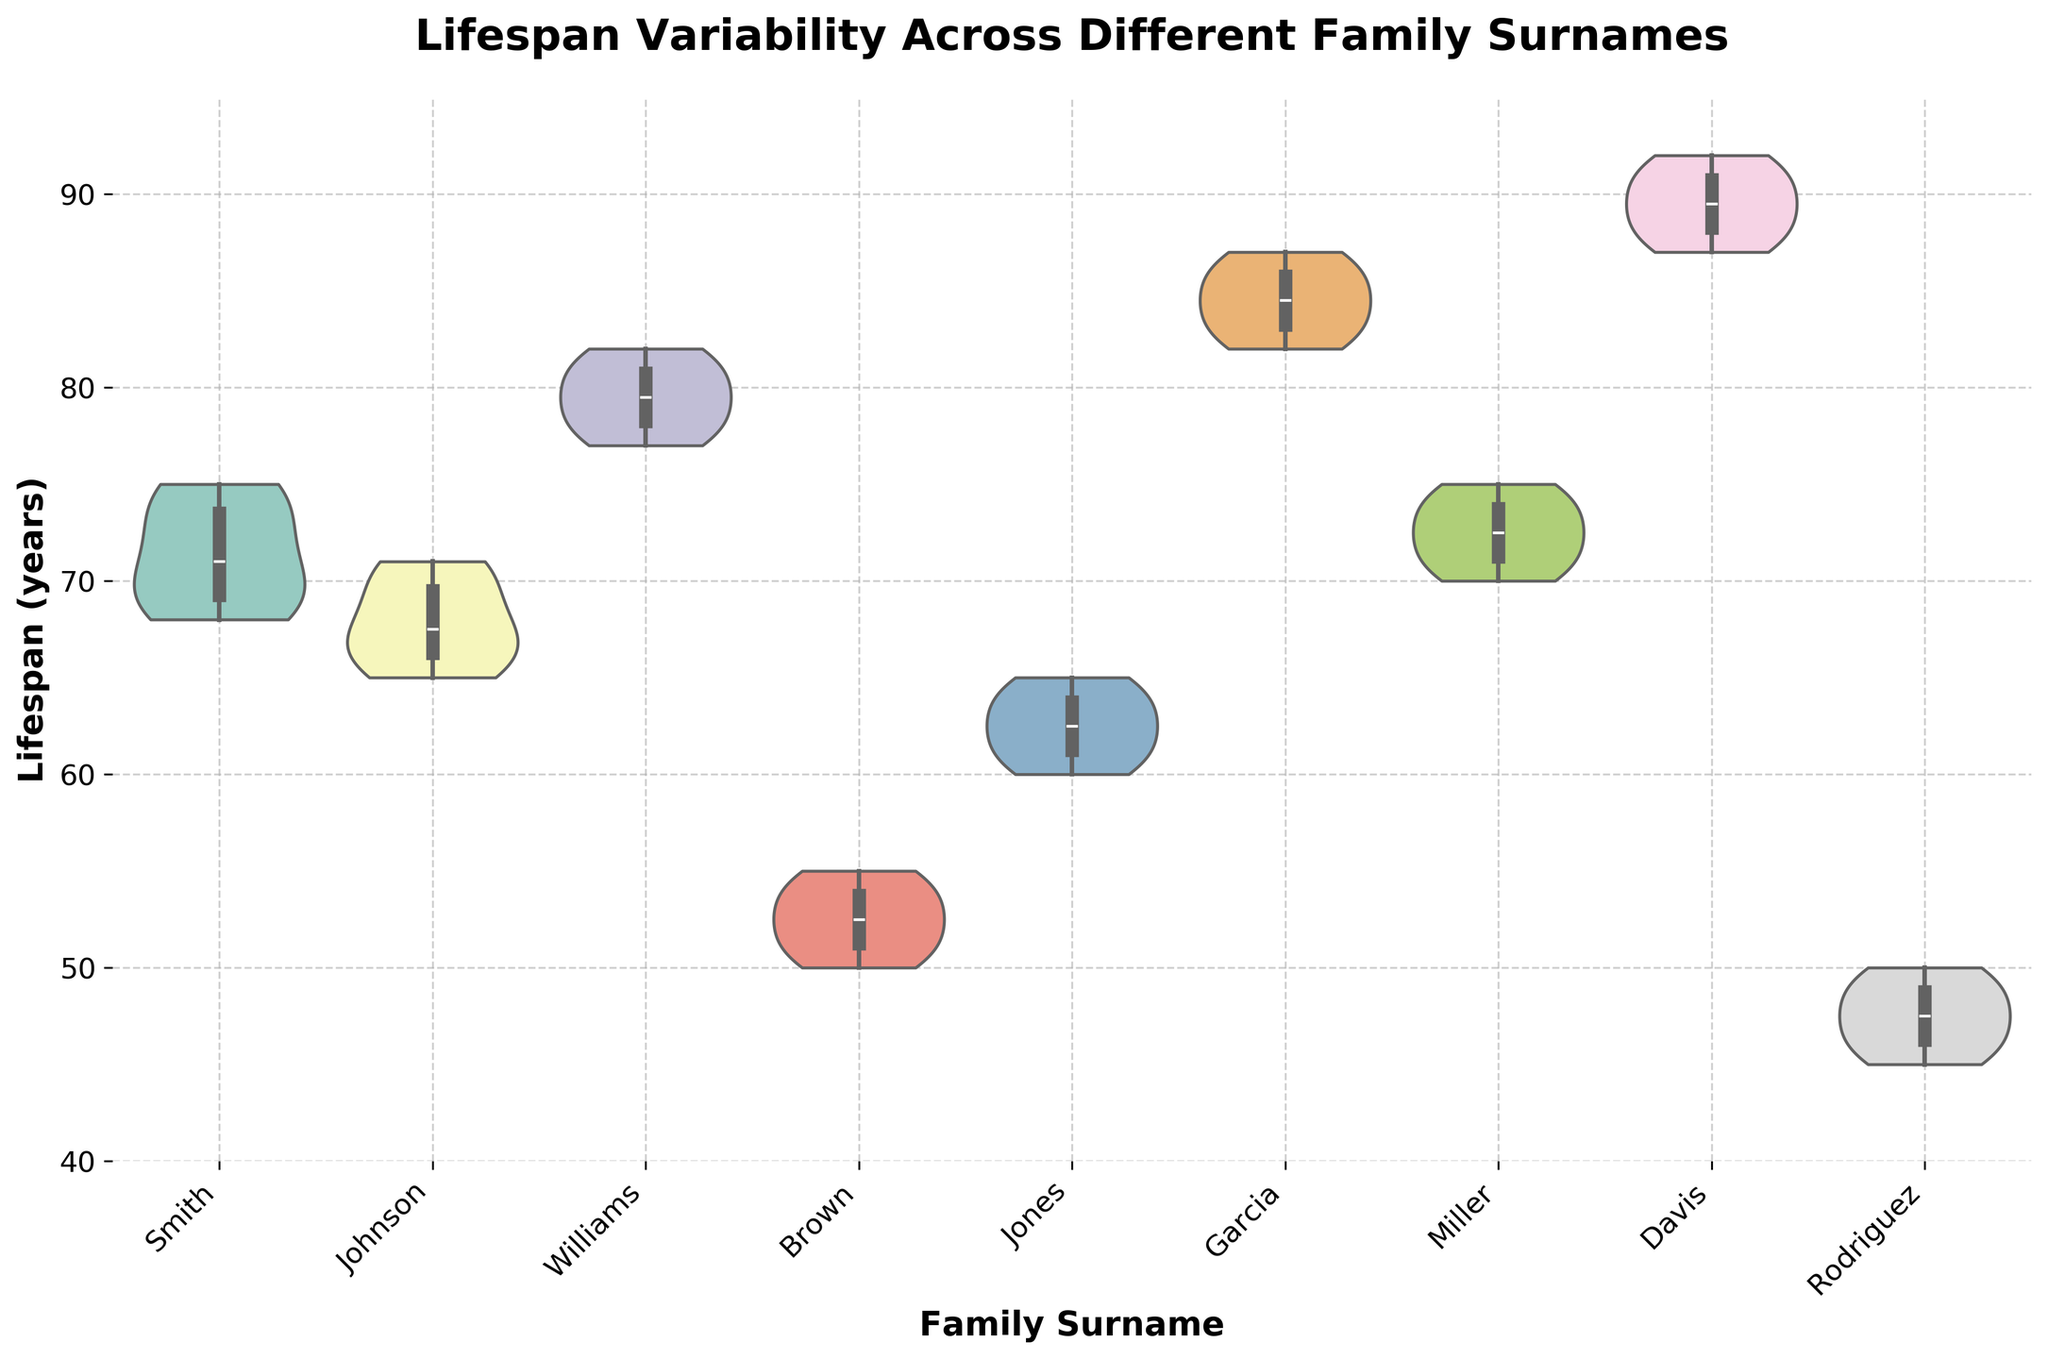What is the title of the figure? The title of the figure can be found at the top of the chart. It is clearly displayed in bold and large font to indicate the main topic of the visualization.
Answer: Lifespan Variability Across Different Family Surnames What is the median lifespan for the Williams family? To find the median lifespan, look inside the box portion of the box plot overlaid on the violin plot. The median is indicated by a horizontal line within the box. For the Williams family, this line appears at around 80 years.
Answer: 80 years Which surname has the greatest range of lifespans? The range can be determined by the span of the violin plot from the minimum to the maximum values. The Davis family has the most extensive span, from 87 to 92 years.
Answer: Davis What is the interquartile range (IQR) for the Garcia family? The interquartile range can be found within the box portion of the box plot by subtracting the lower quartile value from the upper quartile value. For the Garcia family, the lower quartile (Q1) is around 82 years, and the upper quartile (Q3) is around 86 years, so the IQR is 86 - 82 = 4 years.
Answer: 4 years Which two families have the closest median lifespans? By locating the horizontal median lines within the boxes of each box plot, the Smith (around 72 years) and Miller (around 72 years) families have the closest median lifespans.
Answer: Smith and Miller What is the average lifespan for the Johnson family based on the plot? To find the average, observe the center of the distribution in the violin plot. The Johnson family has lifespans around the central concentration, approximately centered around 68 years.
Answer: 68 years Which family's lifespan distribution is the most symmetrical? A symmetrical distribution has a mirror-image appearance on either side of the median. The Garcia family's violin plot shows a fairly symmetrical distribution around the median.
Answer: Garcia How does the variability of the Brown family's lifespan compare to that of the Rodriguez family? Variability can be assessed by the width and spread of the violin plots. The Brown family has a more concentrated, narrower spread (about 50 to 55 years), indicating lower variability compared to the Rodriguez family (45 to 50 years), which shows more spread.
Answer: Brown has lower variability than Rodriguez 